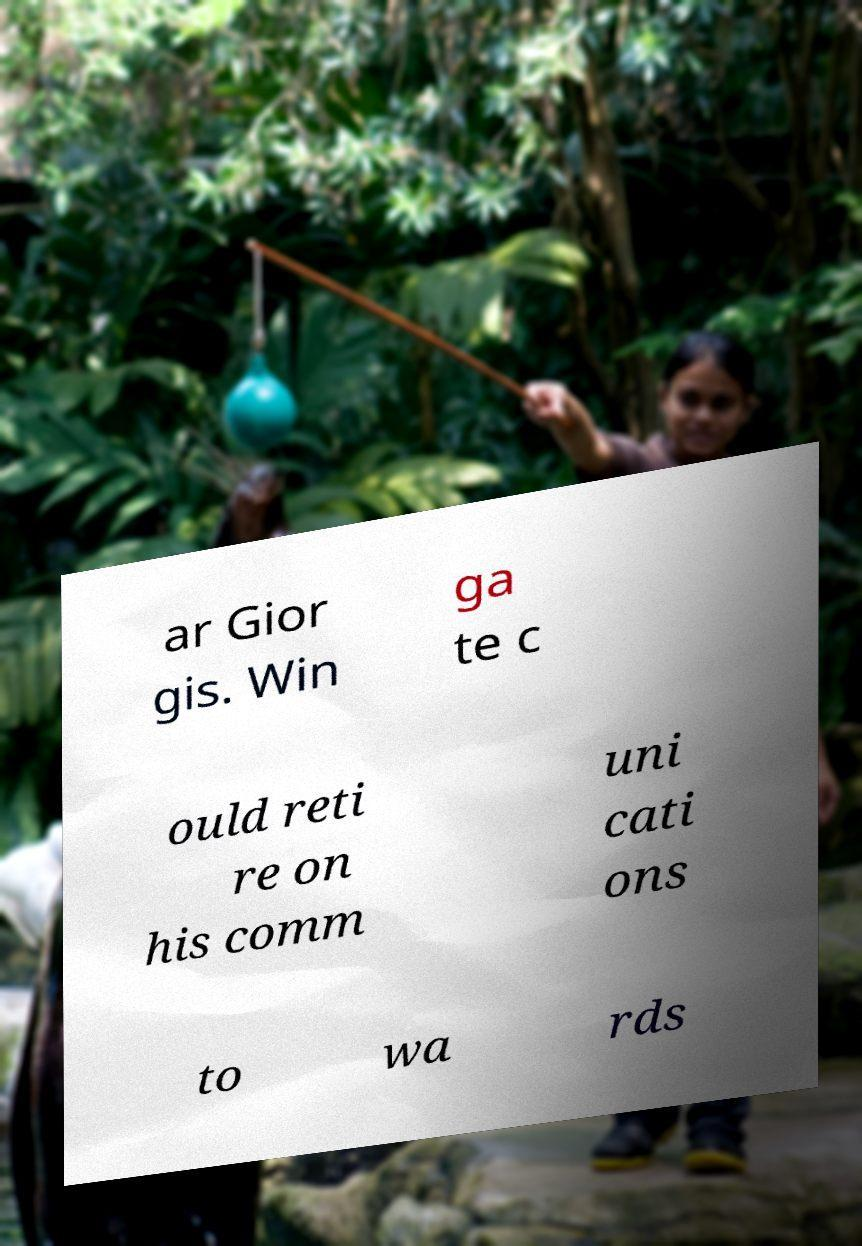Please read and relay the text visible in this image. What does it say? ar Gior gis. Win ga te c ould reti re on his comm uni cati ons to wa rds 